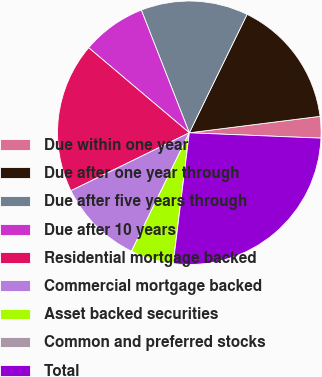Convert chart. <chart><loc_0><loc_0><loc_500><loc_500><pie_chart><fcel>Due within one year<fcel>Due after one year through<fcel>Due after five years through<fcel>Due after 10 years<fcel>Residential mortgage backed<fcel>Commercial mortgage backed<fcel>Asset backed securities<fcel>Common and preferred stocks<fcel>Total<nl><fcel>2.64%<fcel>15.79%<fcel>13.16%<fcel>7.9%<fcel>18.42%<fcel>10.53%<fcel>5.27%<fcel>0.01%<fcel>26.31%<nl></chart> 